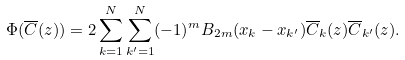Convert formula to latex. <formula><loc_0><loc_0><loc_500><loc_500>\Phi ( \overline { C } ( z ) ) = 2 \sum _ { k = 1 } ^ { N } \sum _ { k ^ { \prime } = 1 } ^ { N } ( - 1 ) ^ { m } B _ { 2 m } ( x _ { k } - x _ { k ^ { \prime } } ) \overline { C } _ { k } ( z ) \overline { C } _ { k ^ { \prime } } ( z ) .</formula> 